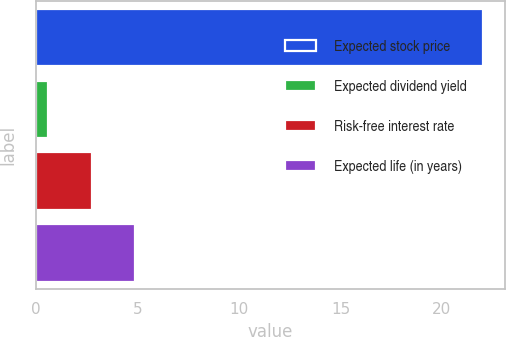Convert chart. <chart><loc_0><loc_0><loc_500><loc_500><bar_chart><fcel>Expected stock price<fcel>Expected dividend yield<fcel>Risk-free interest rate<fcel>Expected life (in years)<nl><fcel>22<fcel>0.6<fcel>2.74<fcel>4.88<nl></chart> 